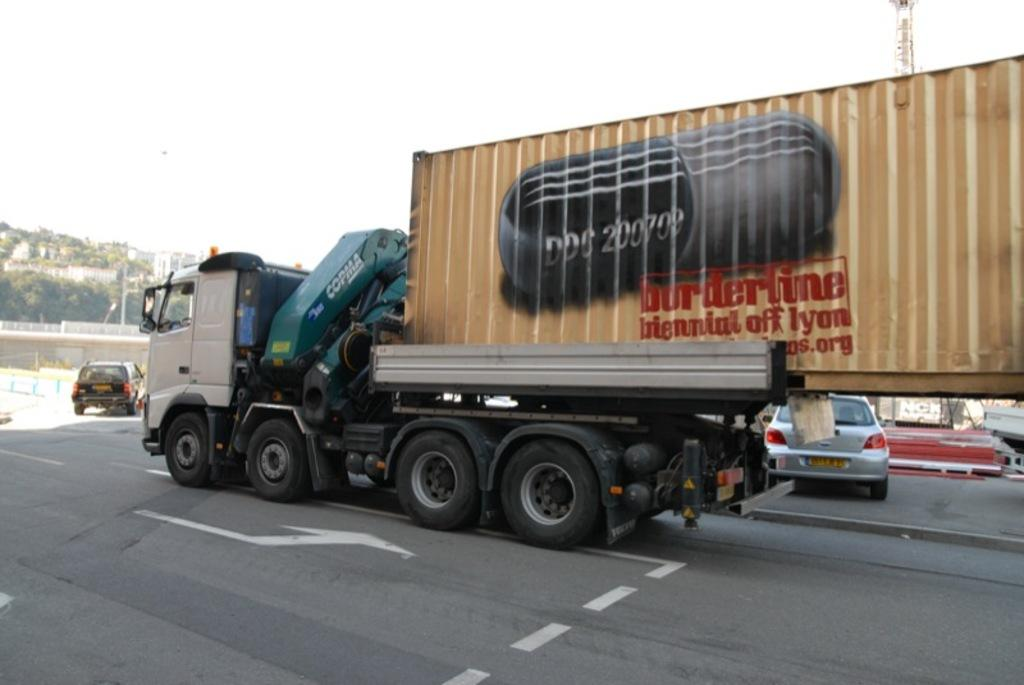What can be seen on the road in the image? There are vehicles on the road in the image. What type of natural elements are visible in the background of the image? There are trees in the background of the image. What type of man-made structures can be seen in the background of the image? There are walls in the background of the image. What else can be seen in the background of the image? There are objects in the background of the image. What part of the natural environment is visible in the background of the image? The sky is visible in the background of the image. Can you see a fireman using a quill to write on a pancake in the image? No, there is no fireman, quill, or pancake present in the image. 